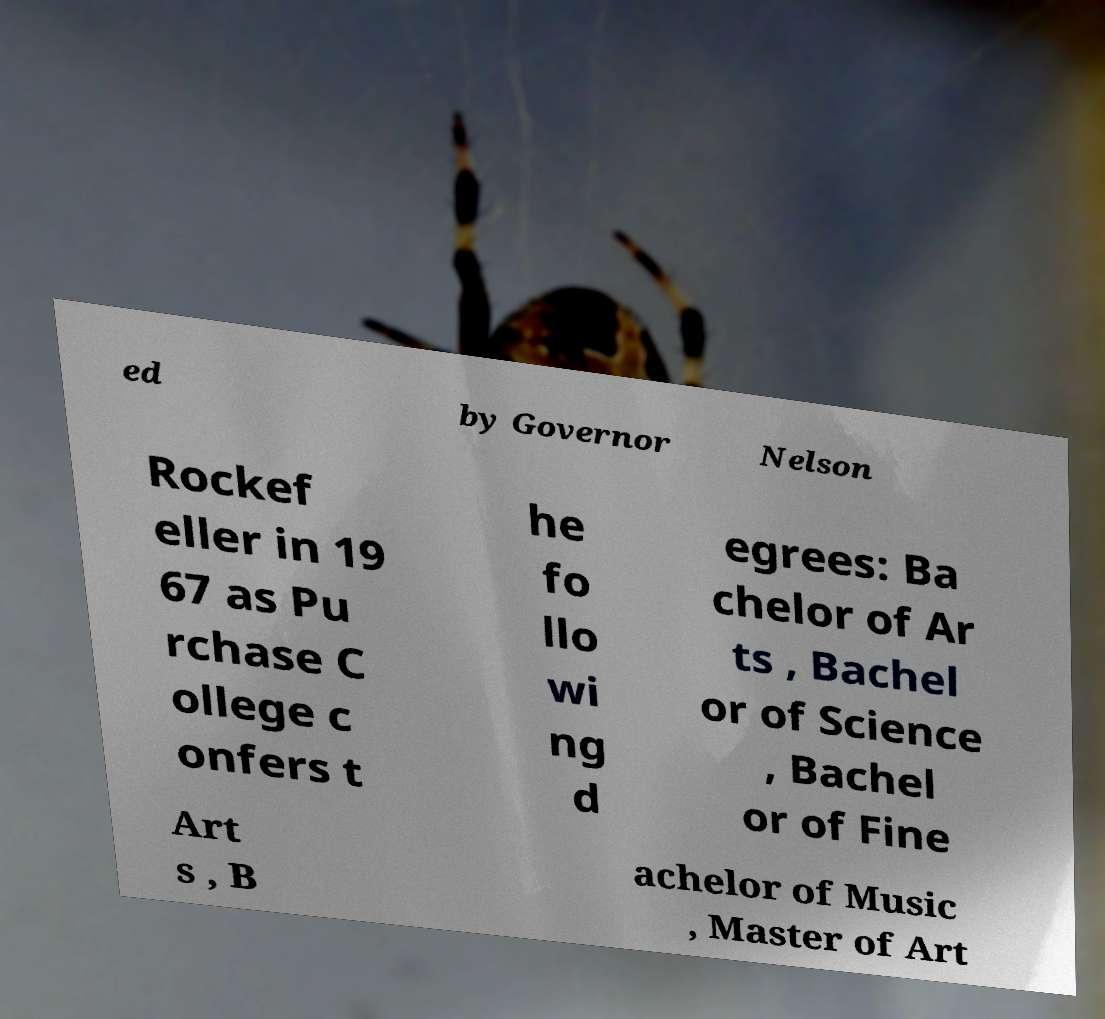Please read and relay the text visible in this image. What does it say? ed by Governor Nelson Rockef eller in 19 67 as Pu rchase C ollege c onfers t he fo llo wi ng d egrees: Ba chelor of Ar ts , Bachel or of Science , Bachel or of Fine Art s , B achelor of Music , Master of Art 